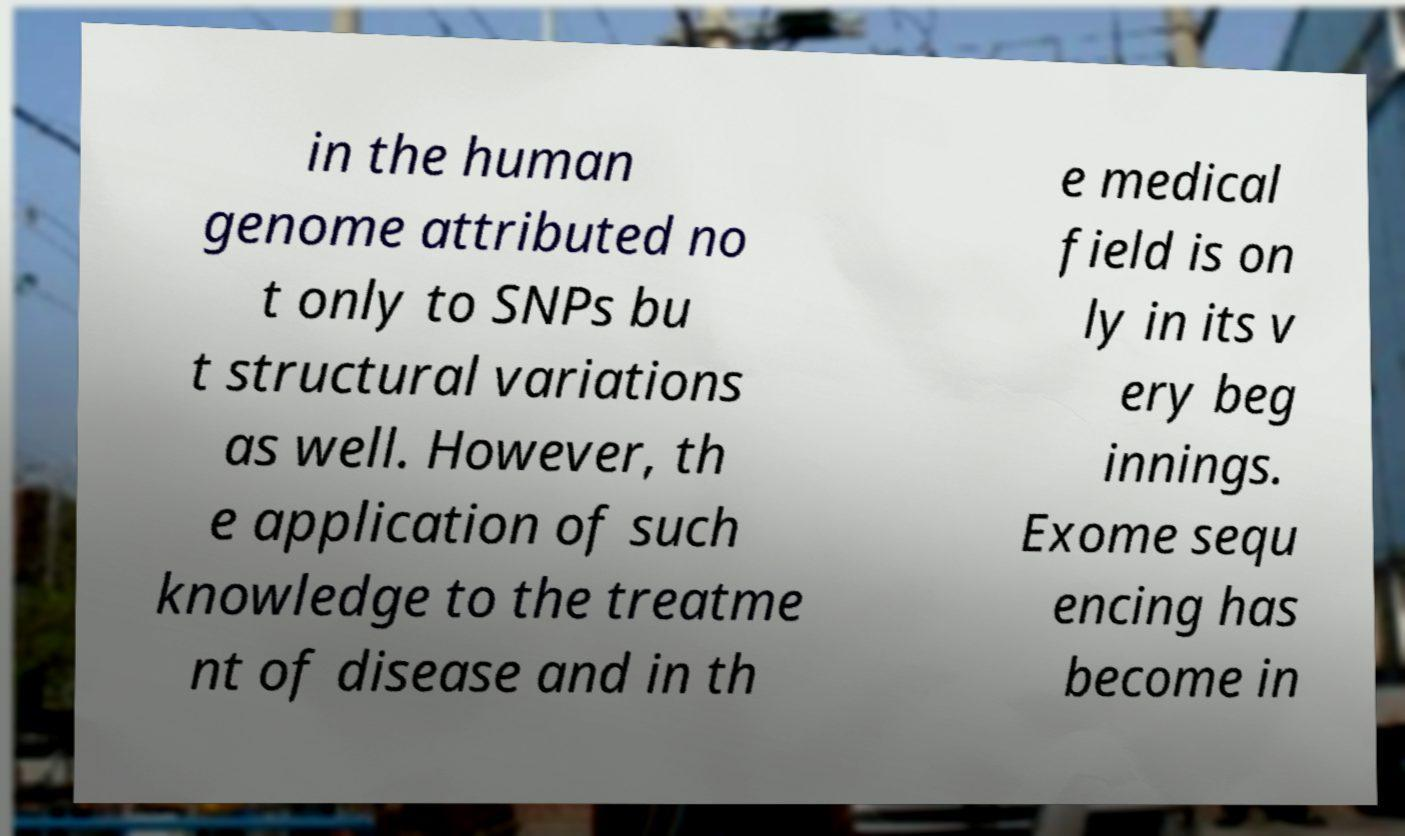Please read and relay the text visible in this image. What does it say? in the human genome attributed no t only to SNPs bu t structural variations as well. However, th e application of such knowledge to the treatme nt of disease and in th e medical field is on ly in its v ery beg innings. Exome sequ encing has become in 